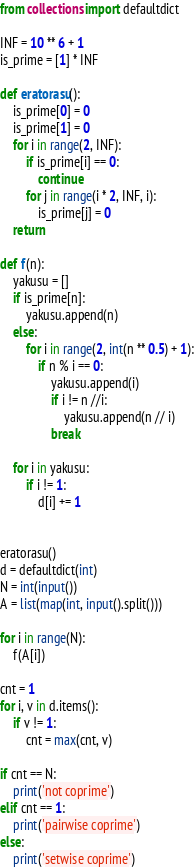Convert code to text. <code><loc_0><loc_0><loc_500><loc_500><_Python_>from collections import defaultdict

INF = 10 ** 6 + 1
is_prime = [1] * INF

def eratorasu():
    is_prime[0] = 0
    is_prime[1] = 0
    for i in range(2, INF):
        if is_prime[i] == 0:
            continue
        for j in range(i * 2, INF, i):
            is_prime[j] = 0
    return

def f(n):
    yakusu = []
    if is_prime[n]:
        yakusu.append(n)
    else:
        for i in range(2, int(n ** 0.5) + 1):
            if n % i == 0:
                yakusu.append(i)
                if i != n //i:
                    yakusu.append(n // i)
                break

    for i in yakusu:
        if i != 1:
            d[i] += 1


eratorasu()
d = defaultdict(int)
N = int(input())
A = list(map(int, input().split()))

for i in range(N):
    f(A[i])

cnt = 1
for i, v in d.items():
    if v != 1:
        cnt = max(cnt, v)

if cnt == N:
    print('not coprime')
elif cnt == 1:
    print('pairwise coprime')
else:
    print('setwise coprime')
</code> 